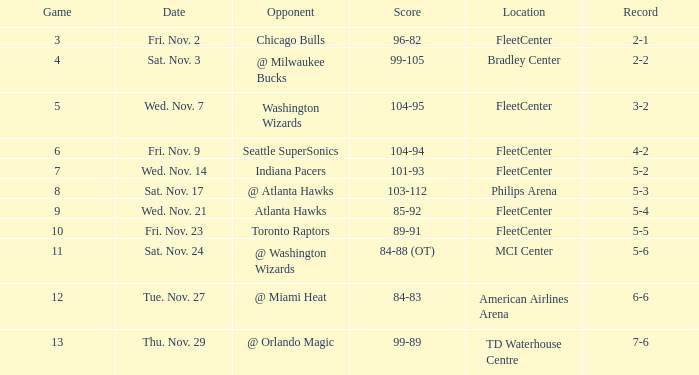On what date did a game higher than 10 have a score of 99-89? Thu. Nov. 29. 